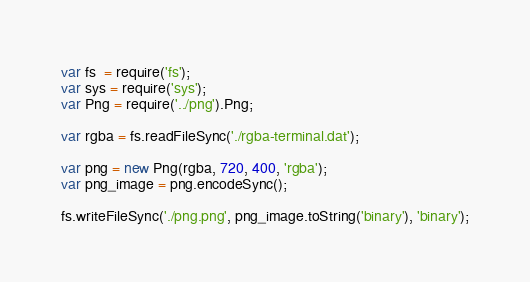<code> <loc_0><loc_0><loc_500><loc_500><_JavaScript_>var fs  = require('fs');
var sys = require('sys');
var Png = require('../png').Png;

var rgba = fs.readFileSync('./rgba-terminal.dat');

var png = new Png(rgba, 720, 400, 'rgba');
var png_image = png.encodeSync();

fs.writeFileSync('./png.png', png_image.toString('binary'), 'binary');

</code> 